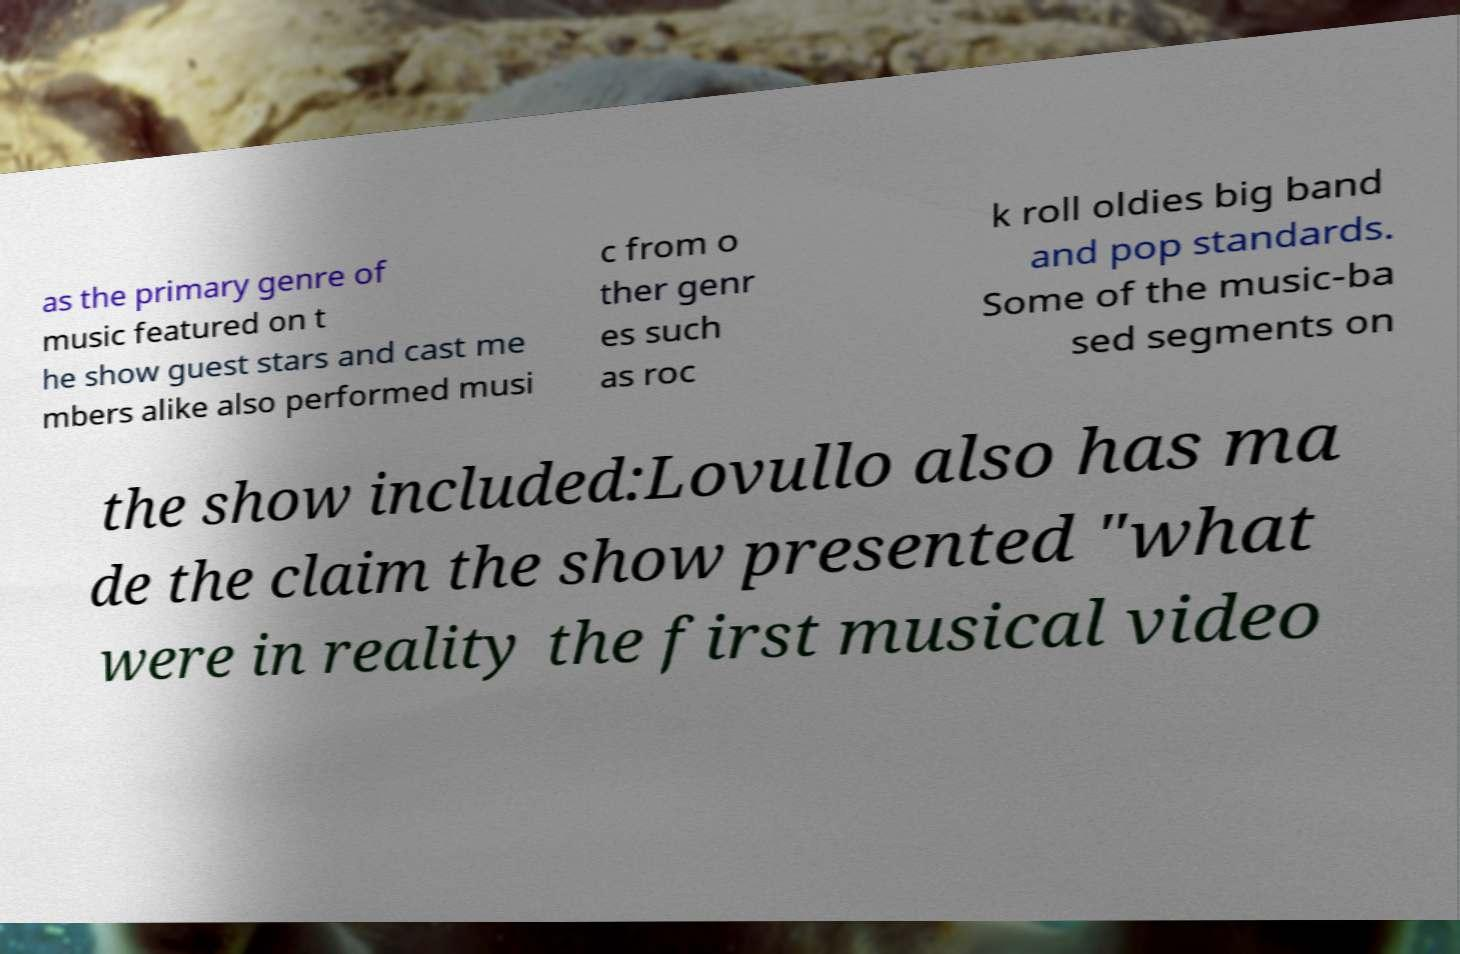Please identify and transcribe the text found in this image. as the primary genre of music featured on t he show guest stars and cast me mbers alike also performed musi c from o ther genr es such as roc k roll oldies big band and pop standards. Some of the music-ba sed segments on the show included:Lovullo also has ma de the claim the show presented "what were in reality the first musical video 